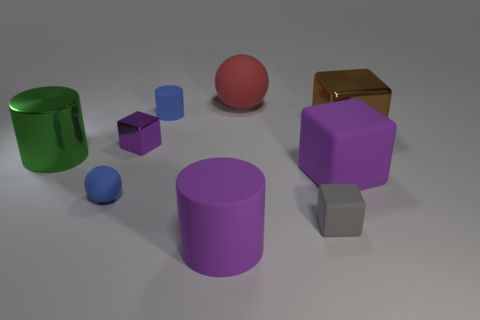There is a tiny ball; is its color the same as the rubber cylinder that is behind the big brown metal object?
Keep it short and to the point. Yes. What number of cubes are either purple things or tiny objects?
Keep it short and to the point. 3. What is the color of the metallic block that is on the left side of the large red rubber object?
Offer a very short reply. Purple. What is the shape of the big matte object that is the same color as the big rubber cylinder?
Keep it short and to the point. Cube. What number of purple things have the same size as the blue rubber ball?
Make the answer very short. 1. There is a small gray thing that is to the right of the green metal thing; is it the same shape as the big shiny object on the right side of the purple shiny thing?
Your answer should be very brief. Yes. What is the material of the tiny block behind the matte block left of the large block that is in front of the large brown shiny thing?
Your response must be concise. Metal. There is a brown metal object that is the same size as the green object; what is its shape?
Offer a terse response. Cube. Is there a big matte block of the same color as the large matte cylinder?
Give a very brief answer. Yes. The brown metal object has what size?
Offer a terse response. Large. 